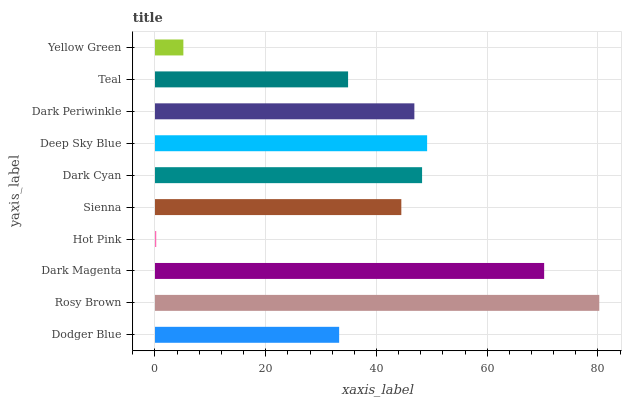Is Hot Pink the minimum?
Answer yes or no. Yes. Is Rosy Brown the maximum?
Answer yes or no. Yes. Is Dark Magenta the minimum?
Answer yes or no. No. Is Dark Magenta the maximum?
Answer yes or no. No. Is Rosy Brown greater than Dark Magenta?
Answer yes or no. Yes. Is Dark Magenta less than Rosy Brown?
Answer yes or no. Yes. Is Dark Magenta greater than Rosy Brown?
Answer yes or no. No. Is Rosy Brown less than Dark Magenta?
Answer yes or no. No. Is Dark Periwinkle the high median?
Answer yes or no. Yes. Is Sienna the low median?
Answer yes or no. Yes. Is Dark Cyan the high median?
Answer yes or no. No. Is Deep Sky Blue the low median?
Answer yes or no. No. 